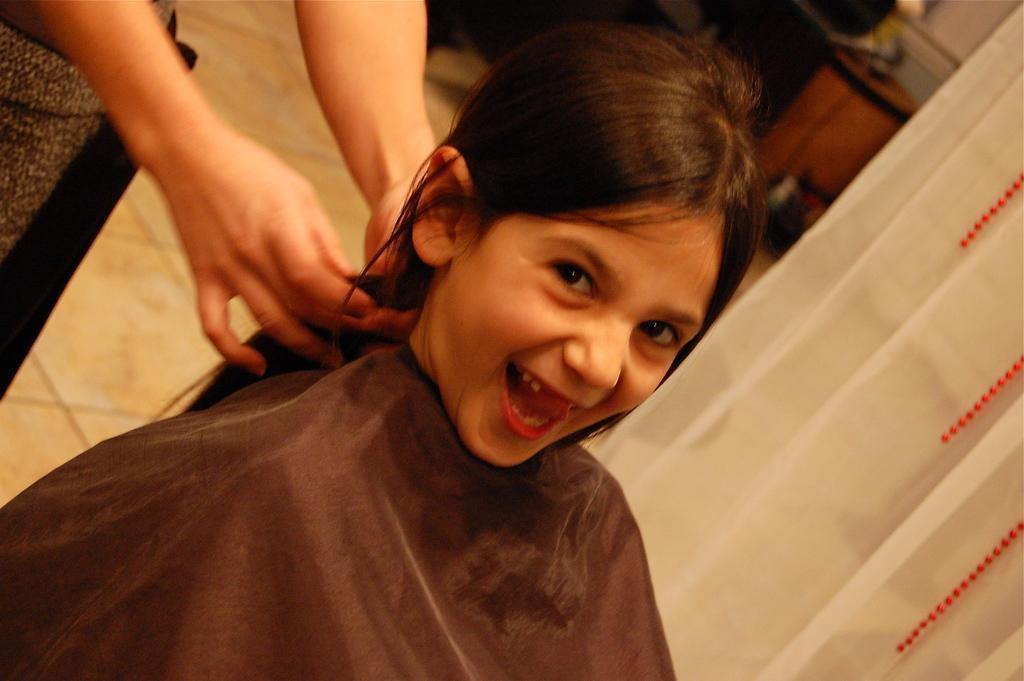Please provide a concise description of this image. The girl at the bottom of the picture is sitting on the chair and she is smiling. Beside her, there is a white color curtain. I think she came for haircut. Behind her, the woman is holding the hairs of the girl. This picture might be clicked in the hair salon. 